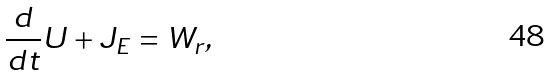<formula> <loc_0><loc_0><loc_500><loc_500>\frac { d } { d t } U + J _ { E } = W _ { r } ,</formula> 